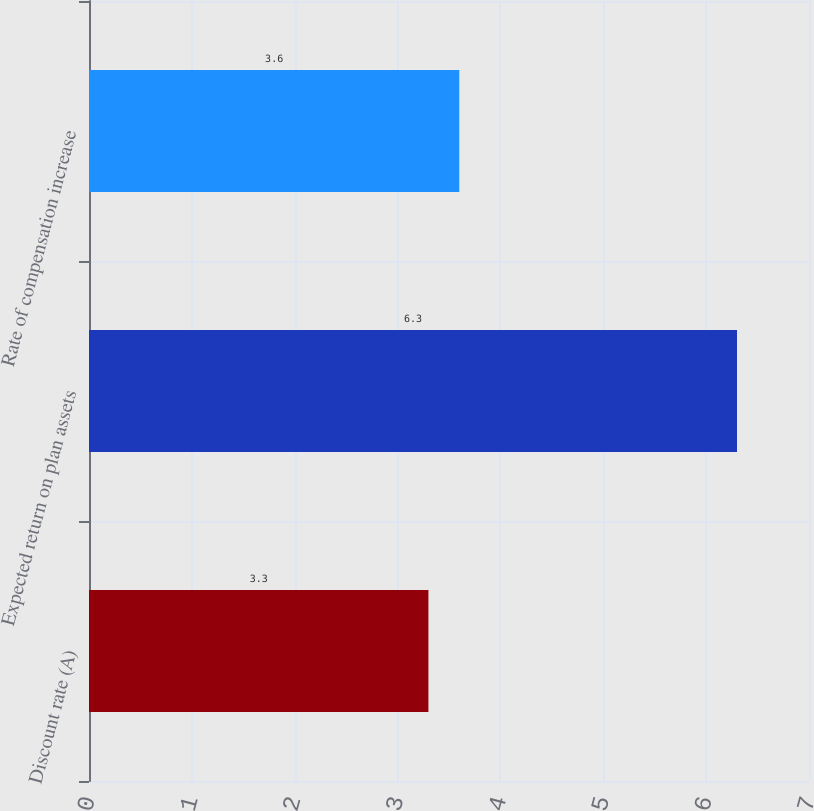Convert chart to OTSL. <chart><loc_0><loc_0><loc_500><loc_500><bar_chart><fcel>Discount rate (A)<fcel>Expected return on plan assets<fcel>Rate of compensation increase<nl><fcel>3.3<fcel>6.3<fcel>3.6<nl></chart> 